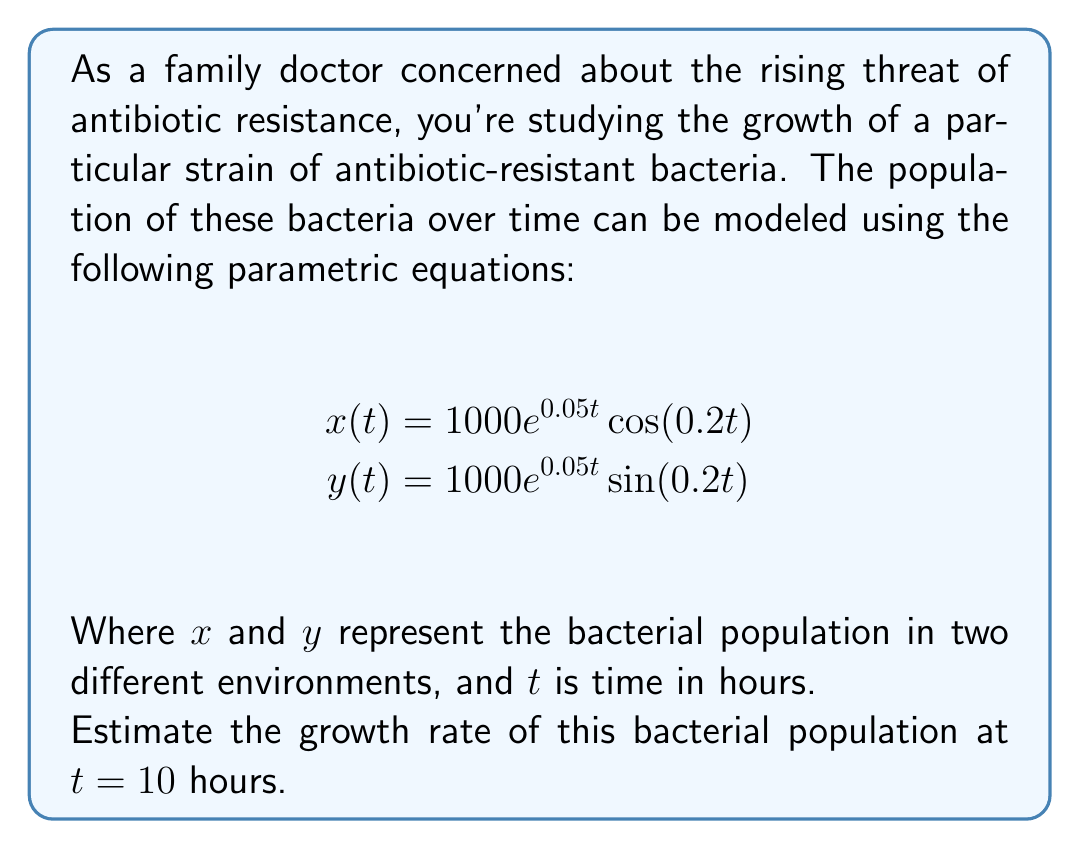Could you help me with this problem? To solve this problem, we need to follow these steps:

1) The total population at any time $t$ is given by:
   $$P(t) = \sqrt{x(t)^2 + y(t)^2}$$

2) Substituting the given equations:
   $$P(t) = \sqrt{(1000e^{0.05t}\cos(0.2t))^2 + (1000e^{0.05t}\sin(0.2t))^2}$$

3) Simplify using the identity $\cos^2(θ) + \sin^2(θ) = 1$:
   $$P(t) = \sqrt{1000^2e^{0.1t}(\cos^2(0.2t) + \sin^2(0.2t))}$$
   $$P(t) = 1000e^{0.05t}$$

4) To find the growth rate, we need to differentiate $P(t)$ with respect to $t$:
   $$\frac{dP}{dt} = 1000 \cdot 0.05e^{0.05t} = 50e^{0.05t}$$

5) At $t = 10$ hours:
   $$\frac{dP}{dt}|_{t=10} = 50e^{0.05(10)} = 50e^{0.5} \approx 82.44$$

This means the population is growing at a rate of approximately 82.44 bacteria per hour at $t = 10$ hours.
Answer: The estimated growth rate of the antibiotic-resistant bacteria at $t = 10$ hours is approximately 82.44 bacteria per hour. 